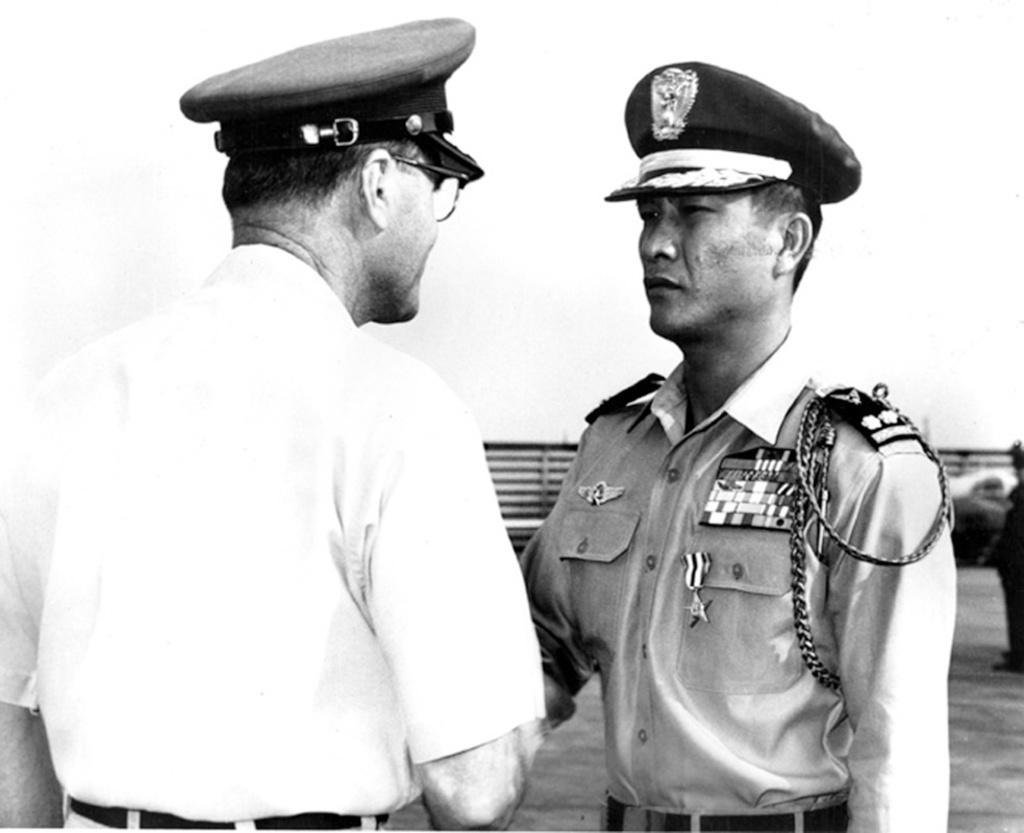Please provide a concise description of this image. In the center of the we can see people standing. They are wearing caps. In the background there is fence. 